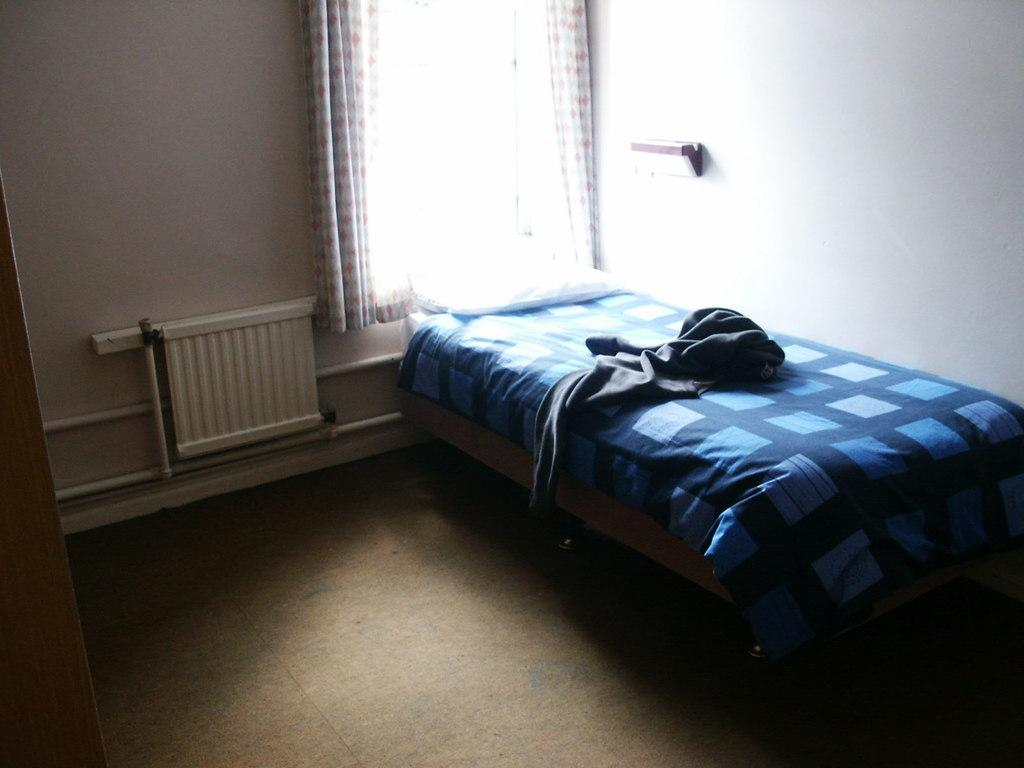What is covering the bed in the image? There is a cloth on the bed. What is placed on the bed for support and comfort? There is a pillow on the bed. What object made of wood can be seen in the image? There is a wooden pole in the image. What is present near the window in the image? There is a window with a curtain in the image. What is used for hanging or storing items in the image? There is a rack in the image. Where is the radiator located in the image? There is a radiator on a wall in the image. What news is being broadcasted from the wooden pole in the image? There is no news broadcasting from the wooden pole in the image; it is simply a wooden object. What type of list is hanging from the rack in the image? There is no list hanging from the rack in the image; it is used for hanging or storing items. 